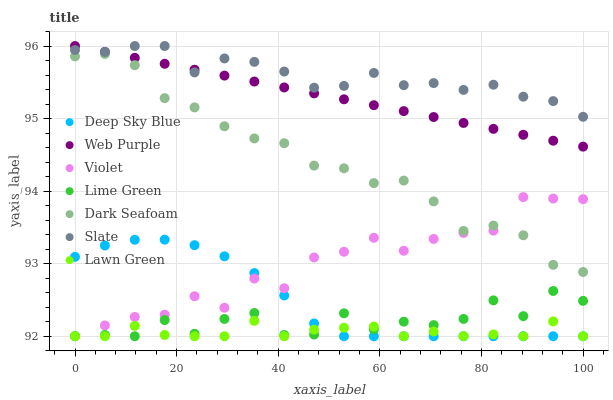Does Lawn Green have the minimum area under the curve?
Answer yes or no. Yes. Does Slate have the maximum area under the curve?
Answer yes or no. Yes. Does Dark Seafoam have the minimum area under the curve?
Answer yes or no. No. Does Dark Seafoam have the maximum area under the curve?
Answer yes or no. No. Is Web Purple the smoothest?
Answer yes or no. Yes. Is Lime Green the roughest?
Answer yes or no. Yes. Is Slate the smoothest?
Answer yes or no. No. Is Slate the roughest?
Answer yes or no. No. Does Lawn Green have the lowest value?
Answer yes or no. Yes. Does Dark Seafoam have the lowest value?
Answer yes or no. No. Does Web Purple have the highest value?
Answer yes or no. Yes. Does Dark Seafoam have the highest value?
Answer yes or no. No. Is Lime Green less than Slate?
Answer yes or no. Yes. Is Dark Seafoam greater than Lime Green?
Answer yes or no. Yes. Does Deep Sky Blue intersect Lawn Green?
Answer yes or no. Yes. Is Deep Sky Blue less than Lawn Green?
Answer yes or no. No. Is Deep Sky Blue greater than Lawn Green?
Answer yes or no. No. Does Lime Green intersect Slate?
Answer yes or no. No. 